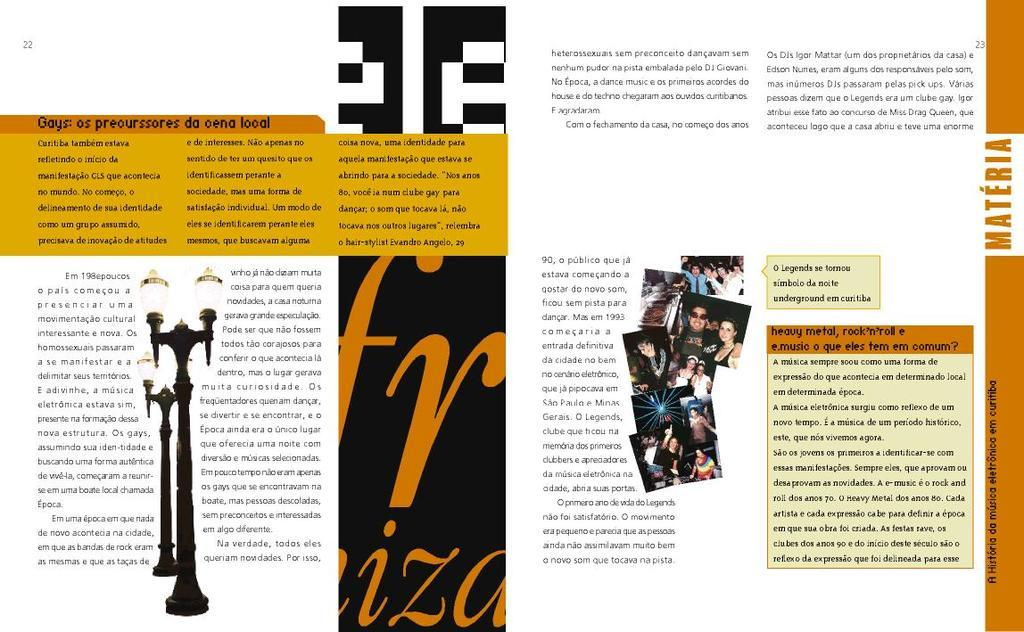What is featured on the poster in the image? There is a poster with information in the image. What can be seen illuminated in the image? There are lights visible in the image. What structures are present in the image? There are poles in the image. Who or what is present in the image? There are people in the image. Where is the faucet located in the image? There is no faucet present in the image. What type of crime is being committed in the image? There is no crime being committed in the image; it features a poster, lights, poles, and people. Are there any umbrellas visible in the image? There are no umbrellas visible in the image. 